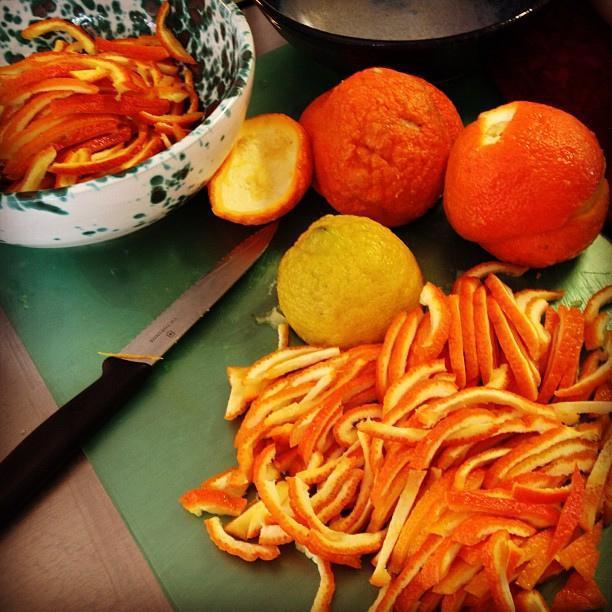How many different type of fruit is in this picture?
Give a very brief answer. 1. How many bowls can you see?
Give a very brief answer. 2. How many oranges are in the photo?
Give a very brief answer. 4. 